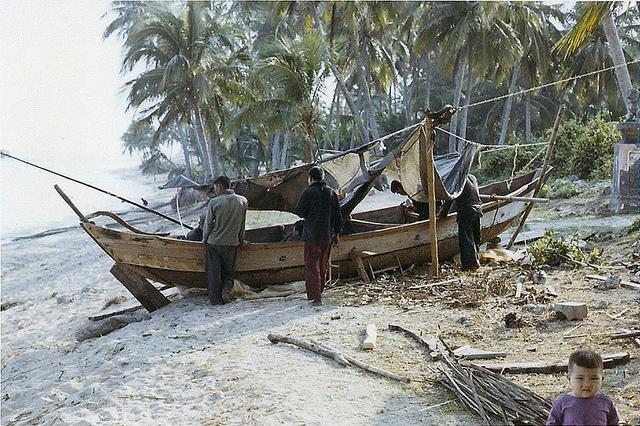What would be the most useful material for adding to the boat in this image? wood 